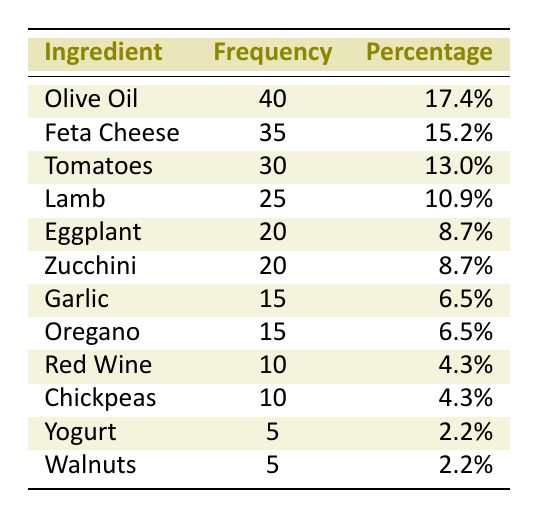What is the ingredient with the highest frequency? In the table, we see that "Olive Oil" has the highest frequency listed at 40. Looking through all the ingredients, none exceed this value.
Answer: Olive Oil What is the frequency of Feta Cheese? Directly referring to the table, we find the frequency for "Feta Cheese" is 35 as noted in its corresponding row.
Answer: 35 Which ingredient appears at a frequency of 20? Looking through the table, "Eggplant" and "Zucchini" both appear with a frequency of 20, as listed in their rows. Thus, there are two ingredients that meet this criteria.
Answer: Eggplant and Zucchini What is the total frequency of the top three ingredients? The top three ingredients by frequency are "Olive Oil" (40), "Feta Cheese" (35), and "Tomatoes" (30). Adding these together gives 40 + 35 + 30 = 105 as the total frequency of the top three ingredients.
Answer: 105 Is the frequency of Garlic greater than that of Yogurt? Referring to the table, "Garlic" has a frequency of 15 while "Yogurt" has a frequency of 5. Since 15 is greater than 5, the statement is true.
Answer: Yes What is the percentage of ingredients that have a frequency of 10 or more? We can count the ingredients with frequencies of 10 or more: Olive Oil (40), Feta Cheese (35), Tomatoes (30), Lamb (25), Eggplant (20), Zucchini (20), Garlic (15), Oregano (15), Red Wine (10), and Chickpeas (10), yielding 10 ingredients. There are a total of 12 ingredients listed. Thus, 10/12 gives us approximately 83.3%.
Answer: 83.3% Which ingredient has the lowest frequency? From the table, "Yogurt" and "Walnuts" both have the lowest frequency, listed at 5, where this is the smallest figure when compared with the other ingredient frequencies in the table.
Answer: Yogurt and Walnuts What is the combined frequency of Garlic and Oregano? In the table, "Garlic" has a frequency of 15, and "Oregano" also has a frequency of 15. Adding them together gives 15 + 15 = 30 as their combined frequency.
Answer: 30 